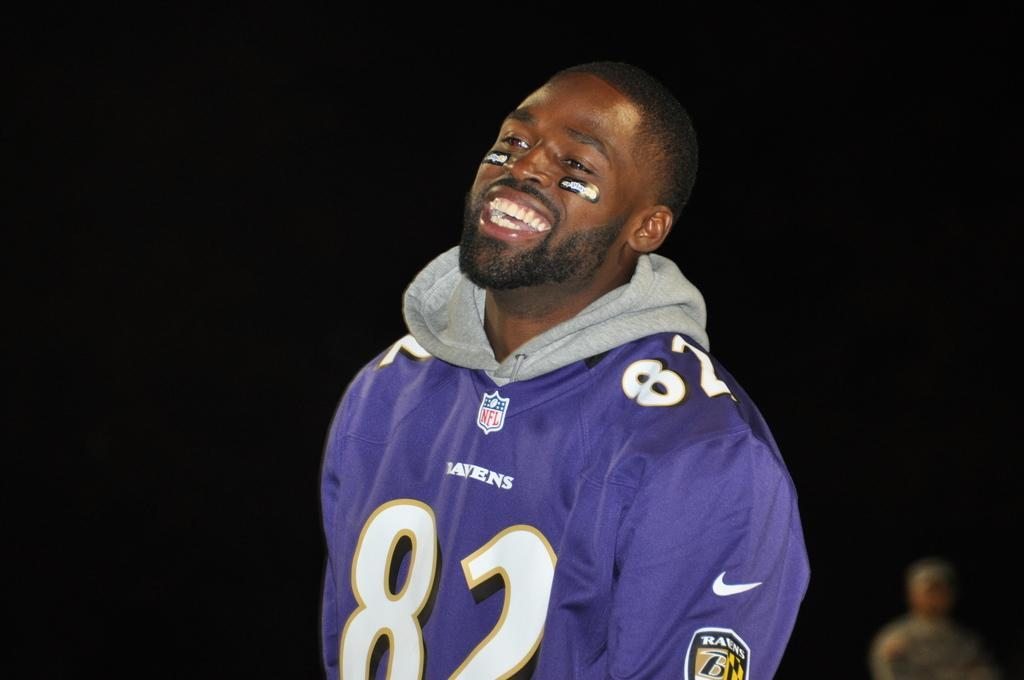Provide a one-sentence caption for the provided image. man in a jersey with the number 82 written acrosss. 